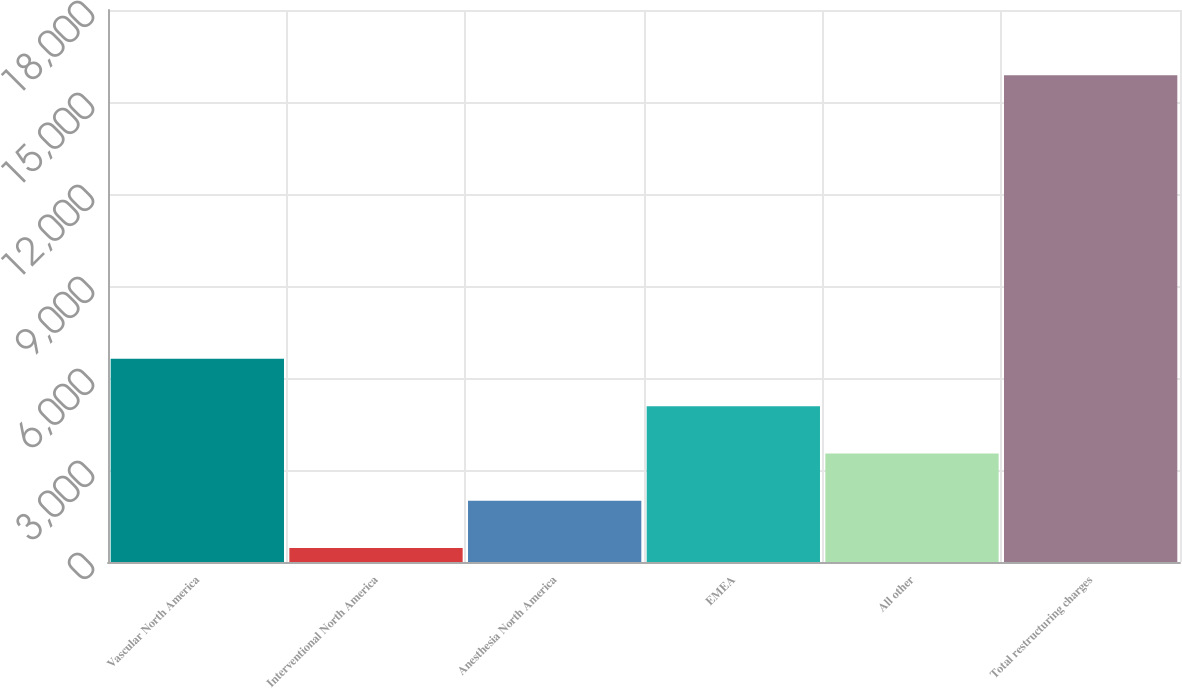Convert chart to OTSL. <chart><loc_0><loc_0><loc_500><loc_500><bar_chart><fcel>Vascular North America<fcel>Interventional North America<fcel>Anesthesia North America<fcel>EMEA<fcel>All other<fcel>Total restructuring charges<nl><fcel>6623.8<fcel>459<fcel>2000.2<fcel>5082.6<fcel>3541.4<fcel>15871<nl></chart> 